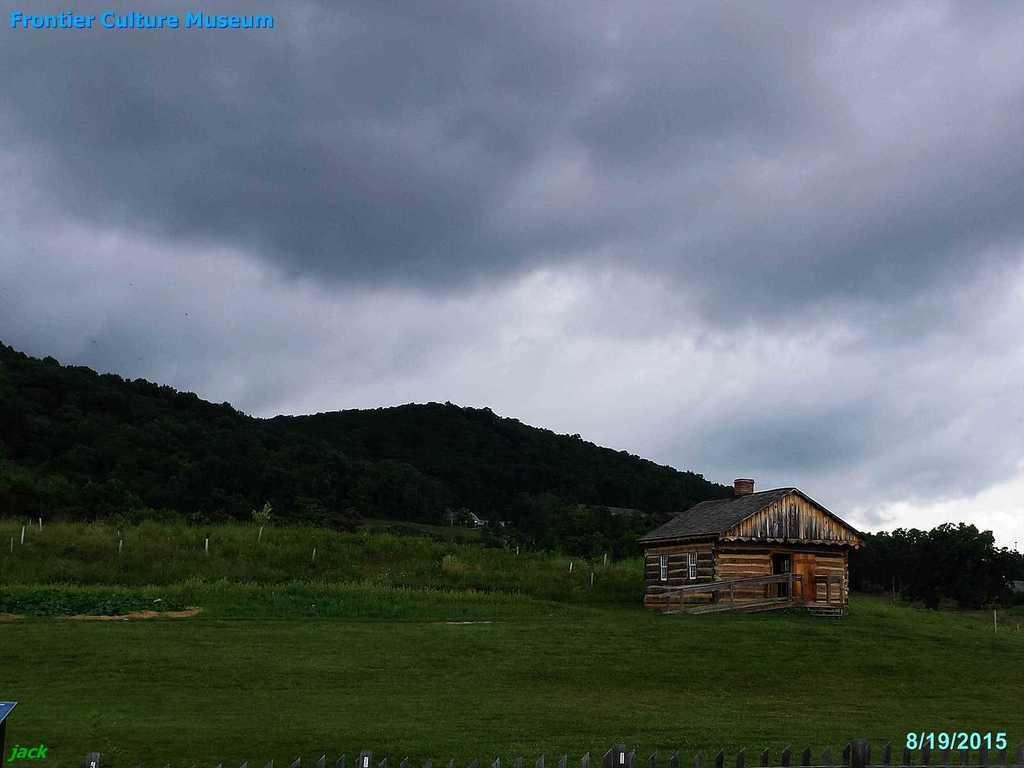In one or two sentences, can you explain what this image depicts? On the right side of the image there is a shed. At the bottom there is a fence and grass. In the background there are hills and sky. 